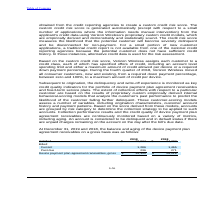According to Consolidated Communications Holdings's financial document, How is the delinquency and write-off experience monitored? as key credit quality indicators for the portfolio of device payment plan agreement receivables and fixed-term service plans.. The document states: "delinquency and write-off experience is monitored as key credit quality indicators for the portfolio of device payment plan agreement receivables and ..." Also, What does the customer-scoring models assess? The document contains multiple relevant values: origination characteristics, customer account history, payment patterns. From the document: "ion characteristics, customer account history and payment patterns. Based on the score derived from these models, accounts are grouped by risk categor..." Also, What was the unbilled in 2019? According to the financial document, $ 22,827. The relevant text states: "Unbilled $ 22,827 $ 24,282..." Also, can you calculate: What was the increase / (decrease) in the unbilled from 2018 to 2019? Based on the calculation: 22,827 - 24,282, the result is -1455. This is based on the information: "Unbilled $ 22,827 $ 24,282 Unbilled $ 22,827 $ 24,282..." The key data points involved are: 22,827, 24,282. Also, can you calculate: What was the average current billed for 2018 and 2019? To answer this question, I need to perform calculations using the financial data. The calculation is: (1,286 + 1,465) / 2, which equals 1375.5. This is based on the information: "Current 1,286 1,465 Current 1,286 1,465..." The key data points involved are: 1,286, 1,465. Also, can you calculate: What was the increase / (decrease) in the past due from 2018 to 2019? Based on the calculation: 236 - 271, the result is -35. This is based on the information: "Past due 236 271 Past due 236 271..." The key data points involved are: 236, 271. 